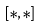<formula> <loc_0><loc_0><loc_500><loc_500>[ * , * ]</formula> 